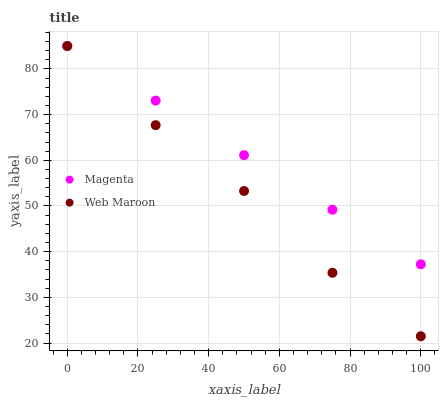Does Web Maroon have the minimum area under the curve?
Answer yes or no. Yes. Does Magenta have the maximum area under the curve?
Answer yes or no. Yes. Does Web Maroon have the maximum area under the curve?
Answer yes or no. No. Is Magenta the smoothest?
Answer yes or no. Yes. Is Web Maroon the roughest?
Answer yes or no. Yes. Is Web Maroon the smoothest?
Answer yes or no. No. Does Web Maroon have the lowest value?
Answer yes or no. Yes. Does Web Maroon have the highest value?
Answer yes or no. Yes. Does Magenta intersect Web Maroon?
Answer yes or no. Yes. Is Magenta less than Web Maroon?
Answer yes or no. No. Is Magenta greater than Web Maroon?
Answer yes or no. No. 